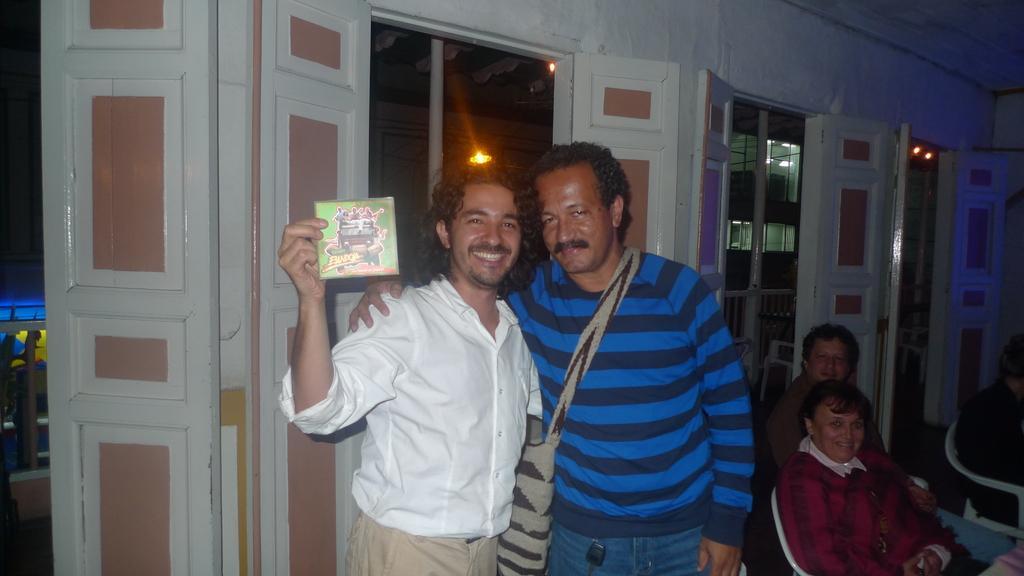How would you summarize this image in a sentence or two? There are two men standing and smiling. This man is holding an object in his hand. I can see few people sitting in the chairs. These are the doors. In the background, I can see the lights. 